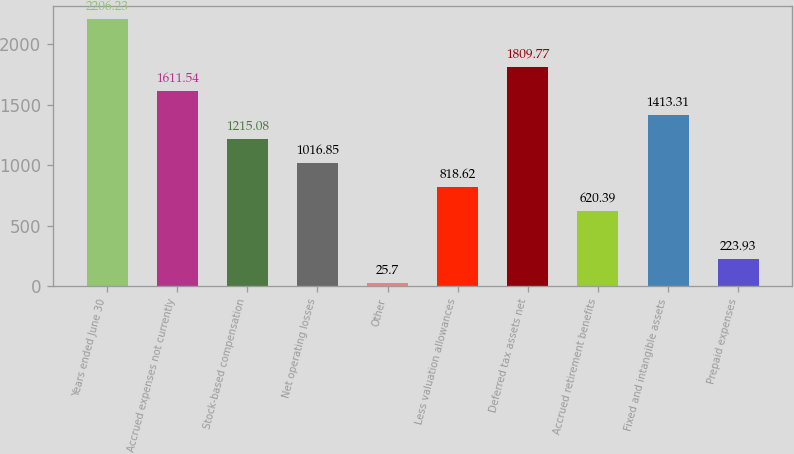Convert chart. <chart><loc_0><loc_0><loc_500><loc_500><bar_chart><fcel>Years ended June 30<fcel>Accrued expenses not currently<fcel>Stock-based compensation<fcel>Net operating losses<fcel>Other<fcel>Less valuation allowances<fcel>Deferred tax assets net<fcel>Accrued retirement benefits<fcel>Fixed and intangible assets<fcel>Prepaid expenses<nl><fcel>2206.23<fcel>1611.54<fcel>1215.08<fcel>1016.85<fcel>25.7<fcel>818.62<fcel>1809.77<fcel>620.39<fcel>1413.31<fcel>223.93<nl></chart> 